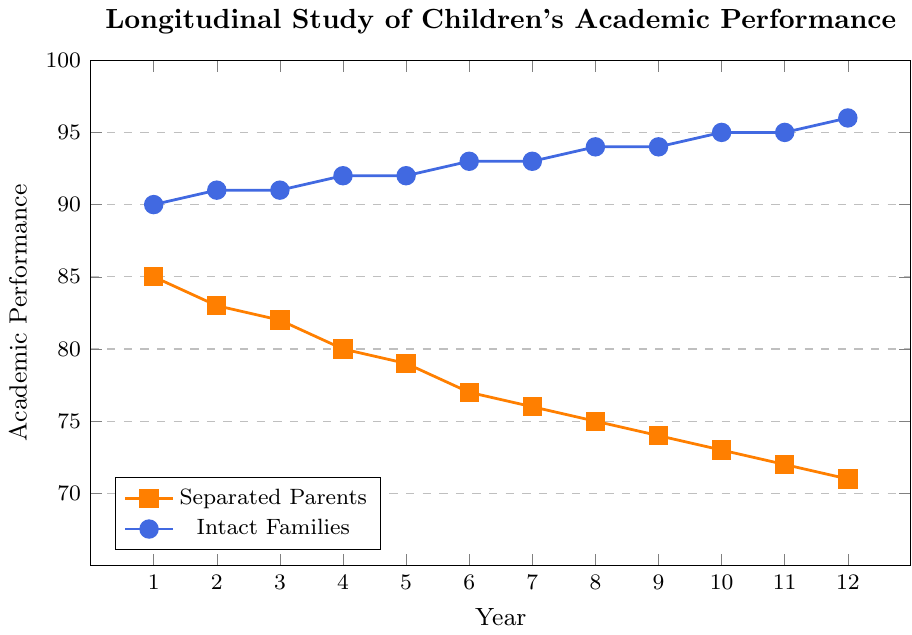What is the academic performance of children from separated parents in Year 6? Locate Year 6 on the x-axis and then find the corresponding y-axis value for the line representing separated parents (orange line with square markers).
Answer: 77 How much did the academic performance of children from intact families increase from Year 1 to Year 12? Identify the performance values for intact families at Year 1 (90) and Year 12 (96) from the corresponding points on the blue line with circular markers. Calculate the difference: 96 - 90.
Answer: 6 What is the average academic performance of children from separated parents over the entire period? Sum the academic performance values of separated parents across all years (85 + 83 + 82 + 80 + 79 + 77 + 76 + 75 + 74 + 73 + 72 + 71) and then divide by the total number of years (12). Average = (85 + 83 + 82 + 80 + 79 + 77 + 76 + 75 + 74 + 73 + 72 + 71) / 12.
Answer: 77 Which year shows the smallest gap in academic performance between children from separated parents and children from intact families? Calculate the performance gaps for each year by subtracting the performance of separated parents from intact families at each year and identify the year with the smallest difference: (e.g., 90 - 85 for Year 1, etc.). The smallest gap is at Year 1, which is 5 (90 - 85).
Answer: Year 1 How do the trends of academic performance differ between children from separated parents and intact families over the years? Observe the overall trend of both lines. Note that the academic performance of children from separated parents shows a declining trend, while the performance of children from intact families shows an increasing trend.
Answer: Separated parents: decreasing; Intact families: increasing At which year does the academic performance of children from intact families first exceed 93? Locate the point where the performance value of intact families first crosses 93 on the y-axis and check the corresponding year on the x-axis. This happens at Year 6.
Answer: Year 6 What is the difference in academic performance between children from separated parents and intact families in Year 8? Find the performance values at Year 8 for both lines: Separated Parents = 75, Intact Families = 94. Subtract the separated parents' value from the intact families' value: 94 - 75.
Answer: 19 How much does the academic performance of children from separated parents decrease on average per year? Find the total decrease in performance from Year 1 (85) to Year 12 (71): 85 - 71 = 14. To find the average yearly decrease, divide total decrease by the number of years: 14 / 12.
Answer: 1.17 In which year did children from intact families achieve their highest recorded academic performance? Observe the peak point for the line representing intact families (blue line with circular markers). The highest recorded performance is at Year 12, where it reaches 96.
Answer: Year 12 